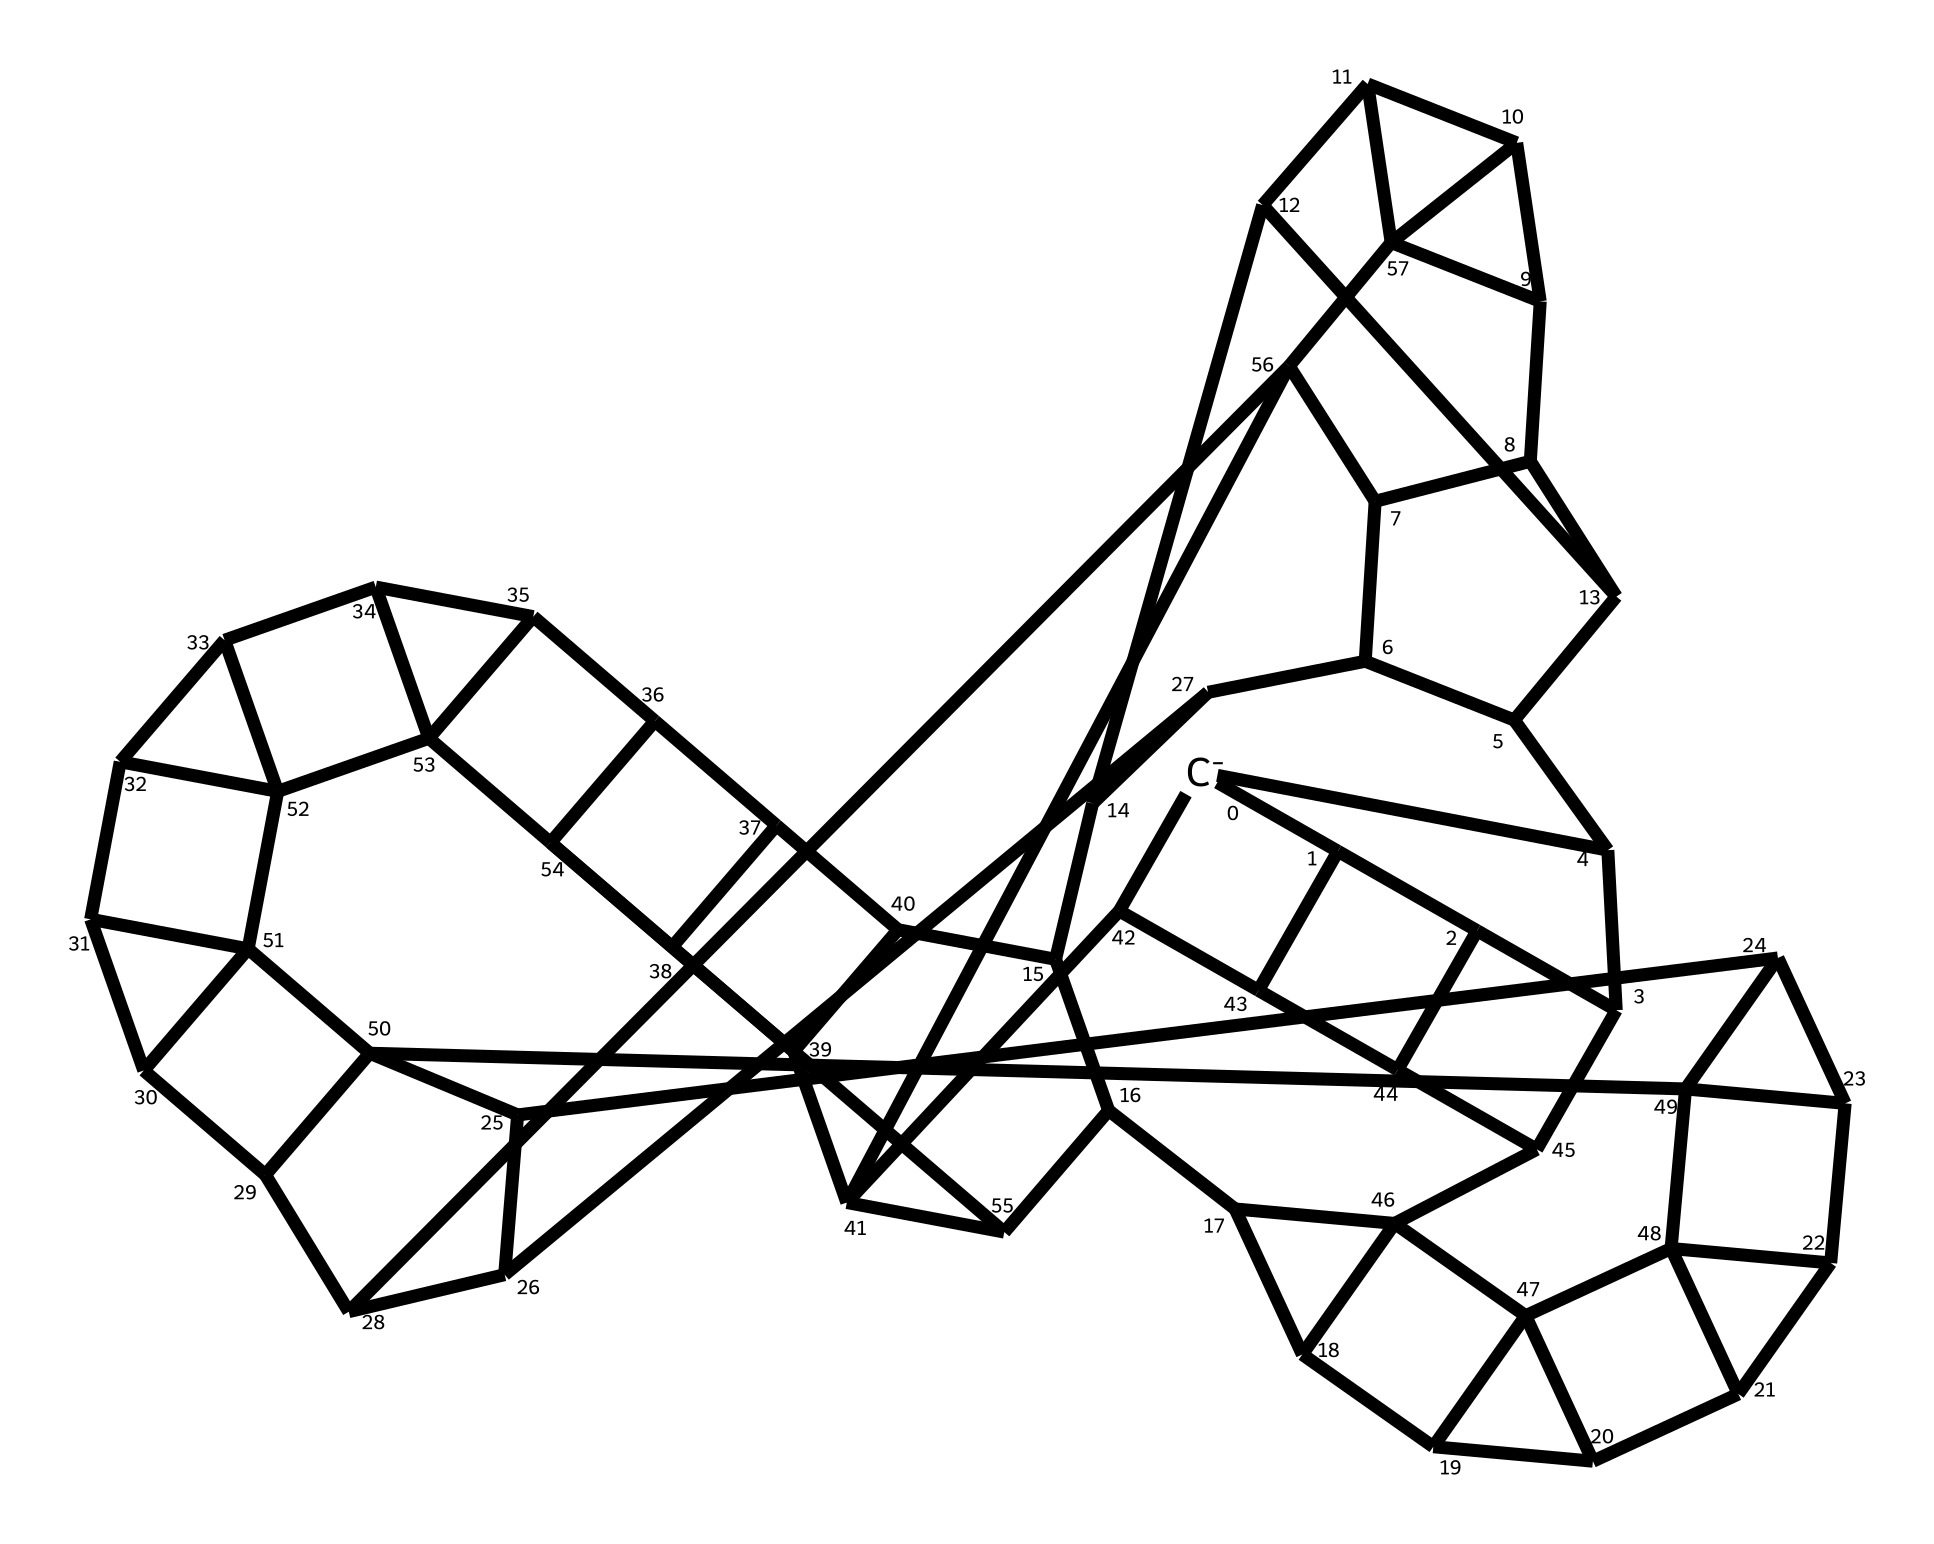What is the overall charge of this fulleride anion? The SMILES indicates that there is a negative charge (shown by the [C-] notation), meaning the overall charge of this fulleride anion is -1.
Answer: -1 How many carbon atoms are present in the structure? Counting the carbon atoms represented in the SMILES notation reveals that there are 70 carbon atoms in total.
Answer: 70 What type of structure does this fulleride represent? Fullerides typically consist of carbon in a hollow cage-like structure. The SMILES suggests a complex arrangement, indicating a fullerene-derived structure common to fullerides.
Answer: cage-like structure How might fulleride anions be involved in pheromone synthesis in insects? Fulleride anions may interact with biological molecules or enzymes, playing a role in synthesizing pheromones, as the structure can interact with various chemical species.
Answer: interact with biological molecules What makes fullerides unique compared to other carbon allotropes? Fullerides are unique due to their spherical or cage-like carbon arrangements, which distinguishes them from other carbon allotropes like graphite or diamond that have planar or tetrahedral structures.
Answer: spherical structure Are fulleride anions stable in biological environments? Stability in biological environments can vary; however, modified fullerides can exhibit stability, making them candidates for biological activity, including pheromone synthesis.
Answer: modified stability 